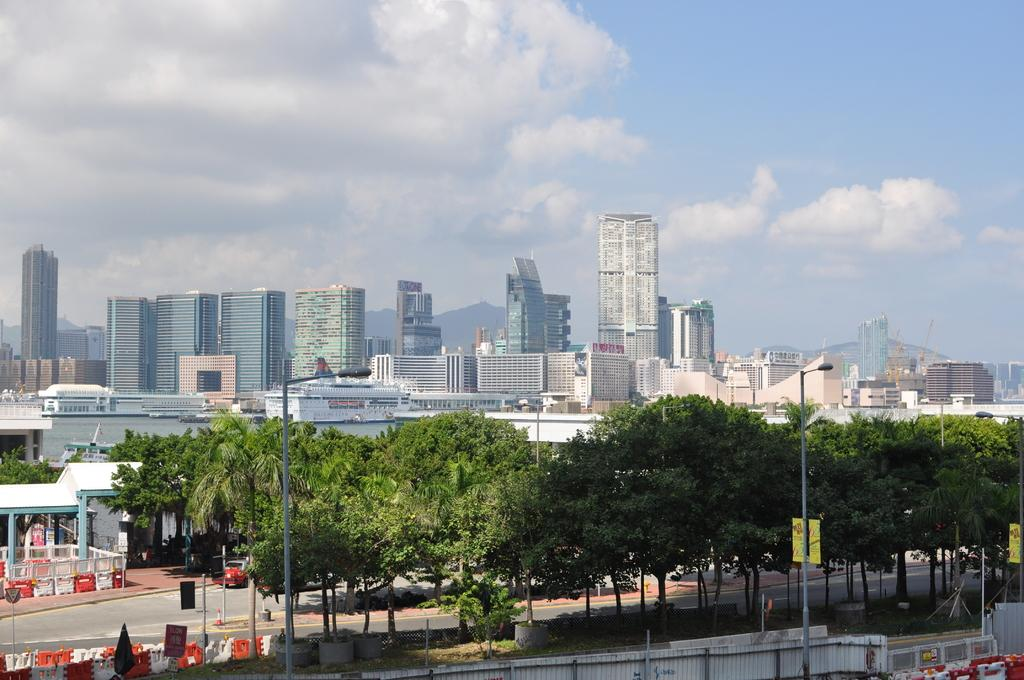What is the condition of the sky in the image? The sky is cloudy in the image. What type of structures can be seen in the image? There are buildings in the image. What are the vertical structures with lights on them called? Light poles are present in the image. What type of advertisement or information boards can be seen in the image? Hoardings are visible in the image. What type of barrier is present in the image? There is a fence in the image. What type of vegetation is present in the image? Trees are present in the image. Reasoning: Let's think step by step by step in order to produce the conversation. We start by identifying the condition of the sky, which is cloudy. Then, we describe the main structures in the image, which are the buildings. Next, we identify specific objects, such as light poles, hoardings, and a fence. Finally, we mention the presence of vegetation, which are the trees. Each question is designed to elicit a specific detail about the image that is known from the provided facts provided. Absurd Question/Answer: What language is spoken by the mice in the image? There are no mice present in the image, so it is not possible to determine the language they might speak. 